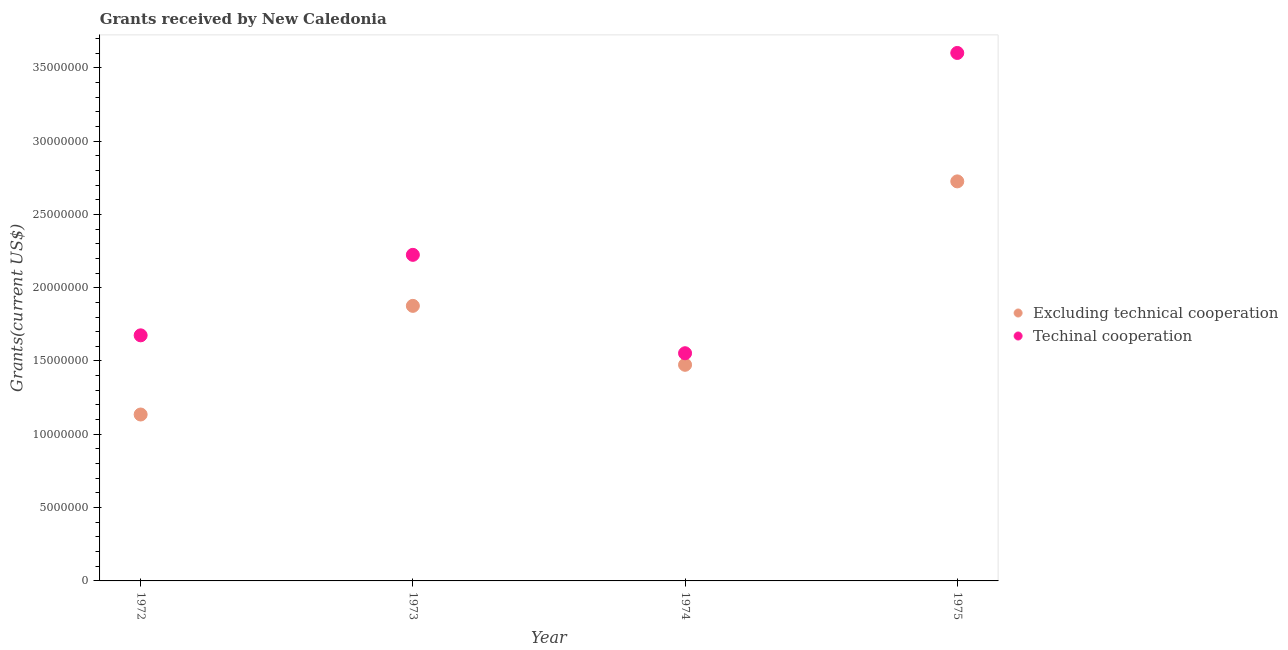Is the number of dotlines equal to the number of legend labels?
Offer a terse response. Yes. What is the amount of grants received(excluding technical cooperation) in 1973?
Provide a short and direct response. 1.88e+07. Across all years, what is the maximum amount of grants received(excluding technical cooperation)?
Keep it short and to the point. 2.72e+07. Across all years, what is the minimum amount of grants received(including technical cooperation)?
Make the answer very short. 1.55e+07. In which year was the amount of grants received(excluding technical cooperation) maximum?
Your answer should be very brief. 1975. What is the total amount of grants received(including technical cooperation) in the graph?
Your response must be concise. 9.05e+07. What is the difference between the amount of grants received(excluding technical cooperation) in 1973 and that in 1974?
Offer a very short reply. 4.02e+06. What is the difference between the amount of grants received(excluding technical cooperation) in 1975 and the amount of grants received(including technical cooperation) in 1974?
Your answer should be very brief. 1.17e+07. What is the average amount of grants received(including technical cooperation) per year?
Offer a very short reply. 2.26e+07. In the year 1972, what is the difference between the amount of grants received(including technical cooperation) and amount of grants received(excluding technical cooperation)?
Your answer should be compact. 5.40e+06. In how many years, is the amount of grants received(excluding technical cooperation) greater than 25000000 US$?
Give a very brief answer. 1. What is the ratio of the amount of grants received(including technical cooperation) in 1972 to that in 1975?
Offer a very short reply. 0.47. Is the difference between the amount of grants received(including technical cooperation) in 1972 and 1974 greater than the difference between the amount of grants received(excluding technical cooperation) in 1972 and 1974?
Make the answer very short. Yes. What is the difference between the highest and the second highest amount of grants received(including technical cooperation)?
Your answer should be very brief. 1.38e+07. What is the difference between the highest and the lowest amount of grants received(excluding technical cooperation)?
Your answer should be very brief. 1.59e+07. Is the amount of grants received(excluding technical cooperation) strictly greater than the amount of grants received(including technical cooperation) over the years?
Your response must be concise. No. How many dotlines are there?
Your answer should be very brief. 2. What is the difference between two consecutive major ticks on the Y-axis?
Keep it short and to the point. 5.00e+06. Does the graph contain any zero values?
Your answer should be compact. No. Does the graph contain grids?
Ensure brevity in your answer.  No. Where does the legend appear in the graph?
Provide a succinct answer. Center right. What is the title of the graph?
Give a very brief answer. Grants received by New Caledonia. Does "Nonresident" appear as one of the legend labels in the graph?
Provide a short and direct response. No. What is the label or title of the X-axis?
Provide a succinct answer. Year. What is the label or title of the Y-axis?
Your answer should be very brief. Grants(current US$). What is the Grants(current US$) of Excluding technical cooperation in 1972?
Ensure brevity in your answer.  1.14e+07. What is the Grants(current US$) of Techinal cooperation in 1972?
Give a very brief answer. 1.68e+07. What is the Grants(current US$) of Excluding technical cooperation in 1973?
Your answer should be compact. 1.88e+07. What is the Grants(current US$) in Techinal cooperation in 1973?
Ensure brevity in your answer.  2.22e+07. What is the Grants(current US$) in Excluding technical cooperation in 1974?
Make the answer very short. 1.47e+07. What is the Grants(current US$) of Techinal cooperation in 1974?
Your answer should be compact. 1.55e+07. What is the Grants(current US$) of Excluding technical cooperation in 1975?
Your response must be concise. 2.72e+07. What is the Grants(current US$) of Techinal cooperation in 1975?
Your answer should be very brief. 3.60e+07. Across all years, what is the maximum Grants(current US$) of Excluding technical cooperation?
Offer a terse response. 2.72e+07. Across all years, what is the maximum Grants(current US$) of Techinal cooperation?
Offer a very short reply. 3.60e+07. Across all years, what is the minimum Grants(current US$) in Excluding technical cooperation?
Make the answer very short. 1.14e+07. Across all years, what is the minimum Grants(current US$) of Techinal cooperation?
Provide a short and direct response. 1.55e+07. What is the total Grants(current US$) of Excluding technical cooperation in the graph?
Offer a terse response. 7.21e+07. What is the total Grants(current US$) in Techinal cooperation in the graph?
Give a very brief answer. 9.05e+07. What is the difference between the Grants(current US$) in Excluding technical cooperation in 1972 and that in 1973?
Your answer should be compact. -7.41e+06. What is the difference between the Grants(current US$) in Techinal cooperation in 1972 and that in 1973?
Give a very brief answer. -5.49e+06. What is the difference between the Grants(current US$) of Excluding technical cooperation in 1972 and that in 1974?
Provide a short and direct response. -3.39e+06. What is the difference between the Grants(current US$) of Techinal cooperation in 1972 and that in 1974?
Make the answer very short. 1.22e+06. What is the difference between the Grants(current US$) of Excluding technical cooperation in 1972 and that in 1975?
Your answer should be very brief. -1.59e+07. What is the difference between the Grants(current US$) in Techinal cooperation in 1972 and that in 1975?
Your answer should be compact. -1.93e+07. What is the difference between the Grants(current US$) in Excluding technical cooperation in 1973 and that in 1974?
Provide a short and direct response. 4.02e+06. What is the difference between the Grants(current US$) of Techinal cooperation in 1973 and that in 1974?
Your answer should be compact. 6.71e+06. What is the difference between the Grants(current US$) of Excluding technical cooperation in 1973 and that in 1975?
Give a very brief answer. -8.49e+06. What is the difference between the Grants(current US$) in Techinal cooperation in 1973 and that in 1975?
Give a very brief answer. -1.38e+07. What is the difference between the Grants(current US$) of Excluding technical cooperation in 1974 and that in 1975?
Provide a short and direct response. -1.25e+07. What is the difference between the Grants(current US$) in Techinal cooperation in 1974 and that in 1975?
Make the answer very short. -2.05e+07. What is the difference between the Grants(current US$) in Excluding technical cooperation in 1972 and the Grants(current US$) in Techinal cooperation in 1973?
Give a very brief answer. -1.09e+07. What is the difference between the Grants(current US$) in Excluding technical cooperation in 1972 and the Grants(current US$) in Techinal cooperation in 1974?
Keep it short and to the point. -4.18e+06. What is the difference between the Grants(current US$) in Excluding technical cooperation in 1972 and the Grants(current US$) in Techinal cooperation in 1975?
Your answer should be compact. -2.47e+07. What is the difference between the Grants(current US$) of Excluding technical cooperation in 1973 and the Grants(current US$) of Techinal cooperation in 1974?
Provide a short and direct response. 3.23e+06. What is the difference between the Grants(current US$) in Excluding technical cooperation in 1973 and the Grants(current US$) in Techinal cooperation in 1975?
Offer a terse response. -1.72e+07. What is the difference between the Grants(current US$) in Excluding technical cooperation in 1974 and the Grants(current US$) in Techinal cooperation in 1975?
Give a very brief answer. -2.13e+07. What is the average Grants(current US$) in Excluding technical cooperation per year?
Provide a short and direct response. 1.80e+07. What is the average Grants(current US$) of Techinal cooperation per year?
Give a very brief answer. 2.26e+07. In the year 1972, what is the difference between the Grants(current US$) in Excluding technical cooperation and Grants(current US$) in Techinal cooperation?
Your answer should be compact. -5.40e+06. In the year 1973, what is the difference between the Grants(current US$) in Excluding technical cooperation and Grants(current US$) in Techinal cooperation?
Your response must be concise. -3.48e+06. In the year 1974, what is the difference between the Grants(current US$) of Excluding technical cooperation and Grants(current US$) of Techinal cooperation?
Ensure brevity in your answer.  -7.90e+05. In the year 1975, what is the difference between the Grants(current US$) in Excluding technical cooperation and Grants(current US$) in Techinal cooperation?
Offer a very short reply. -8.76e+06. What is the ratio of the Grants(current US$) of Excluding technical cooperation in 1972 to that in 1973?
Provide a short and direct response. 0.6. What is the ratio of the Grants(current US$) of Techinal cooperation in 1972 to that in 1973?
Provide a succinct answer. 0.75. What is the ratio of the Grants(current US$) in Excluding technical cooperation in 1972 to that in 1974?
Offer a very short reply. 0.77. What is the ratio of the Grants(current US$) of Techinal cooperation in 1972 to that in 1974?
Give a very brief answer. 1.08. What is the ratio of the Grants(current US$) of Excluding technical cooperation in 1972 to that in 1975?
Keep it short and to the point. 0.42. What is the ratio of the Grants(current US$) in Techinal cooperation in 1972 to that in 1975?
Ensure brevity in your answer.  0.47. What is the ratio of the Grants(current US$) in Excluding technical cooperation in 1973 to that in 1974?
Provide a short and direct response. 1.27. What is the ratio of the Grants(current US$) of Techinal cooperation in 1973 to that in 1974?
Your answer should be compact. 1.43. What is the ratio of the Grants(current US$) of Excluding technical cooperation in 1973 to that in 1975?
Give a very brief answer. 0.69. What is the ratio of the Grants(current US$) in Techinal cooperation in 1973 to that in 1975?
Provide a succinct answer. 0.62. What is the ratio of the Grants(current US$) in Excluding technical cooperation in 1974 to that in 1975?
Provide a short and direct response. 0.54. What is the ratio of the Grants(current US$) in Techinal cooperation in 1974 to that in 1975?
Provide a short and direct response. 0.43. What is the difference between the highest and the second highest Grants(current US$) of Excluding technical cooperation?
Ensure brevity in your answer.  8.49e+06. What is the difference between the highest and the second highest Grants(current US$) of Techinal cooperation?
Your response must be concise. 1.38e+07. What is the difference between the highest and the lowest Grants(current US$) in Excluding technical cooperation?
Give a very brief answer. 1.59e+07. What is the difference between the highest and the lowest Grants(current US$) in Techinal cooperation?
Ensure brevity in your answer.  2.05e+07. 